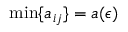Convert formula to latex. <formula><loc_0><loc_0><loc_500><loc_500>\min \{ a _ { i j } \} = a ( \epsilon )</formula> 